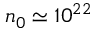<formula> <loc_0><loc_0><loc_500><loc_500>n _ { 0 } \simeq 1 0 ^ { 2 2 }</formula> 